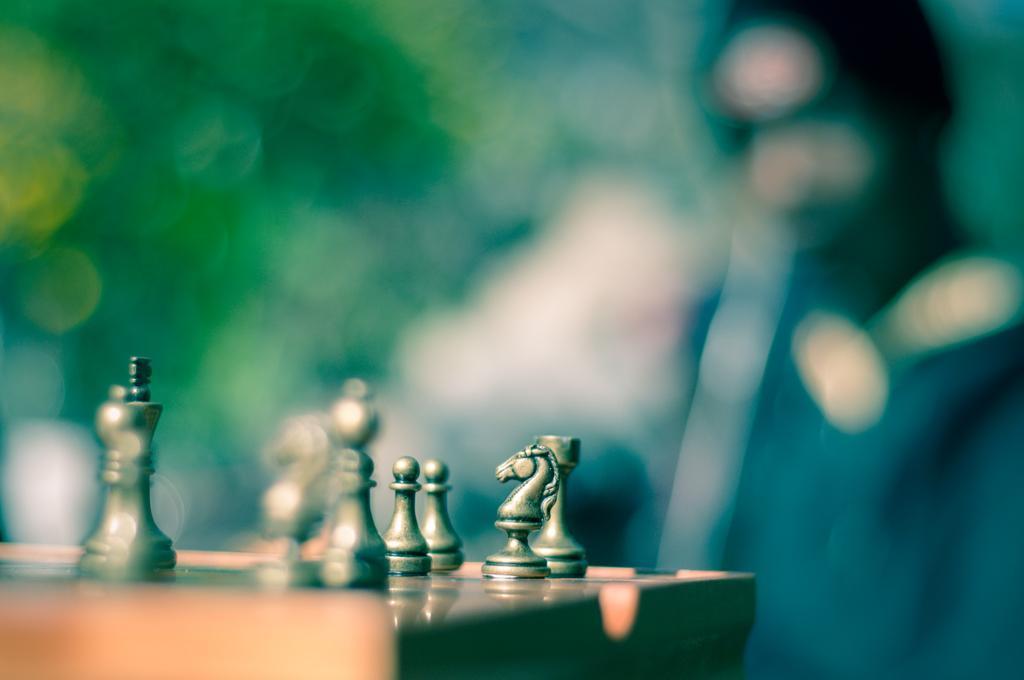Please provide a concise description of this image. In this image, we can see chess coins on the table and the background is blurry. On the right, there is a person. 